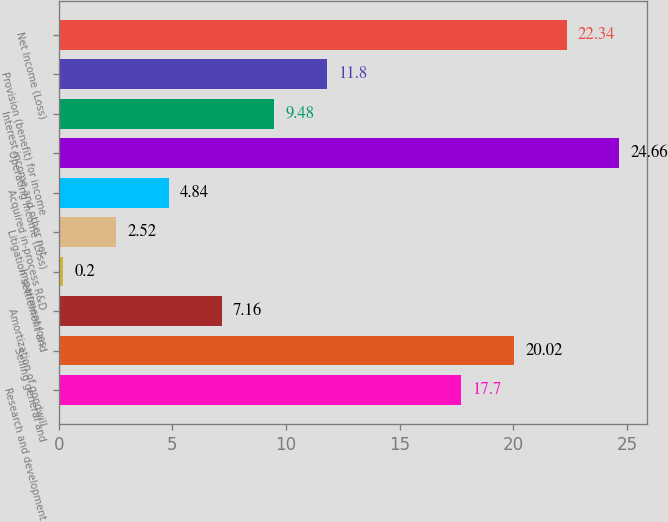Convert chart to OTSL. <chart><loc_0><loc_0><loc_500><loc_500><bar_chart><fcel>Research and development<fcel>Selling general and<fcel>Amortization of goodwill<fcel>Impairment loss<fcel>Litigation settlement and<fcel>Acquired in-process R&D<fcel>Operating Income (Loss)<fcel>Interest income and other net<fcel>Provision (benefit) for income<fcel>Net Income (Loss)<nl><fcel>17.7<fcel>20.02<fcel>7.16<fcel>0.2<fcel>2.52<fcel>4.84<fcel>24.66<fcel>9.48<fcel>11.8<fcel>22.34<nl></chart> 